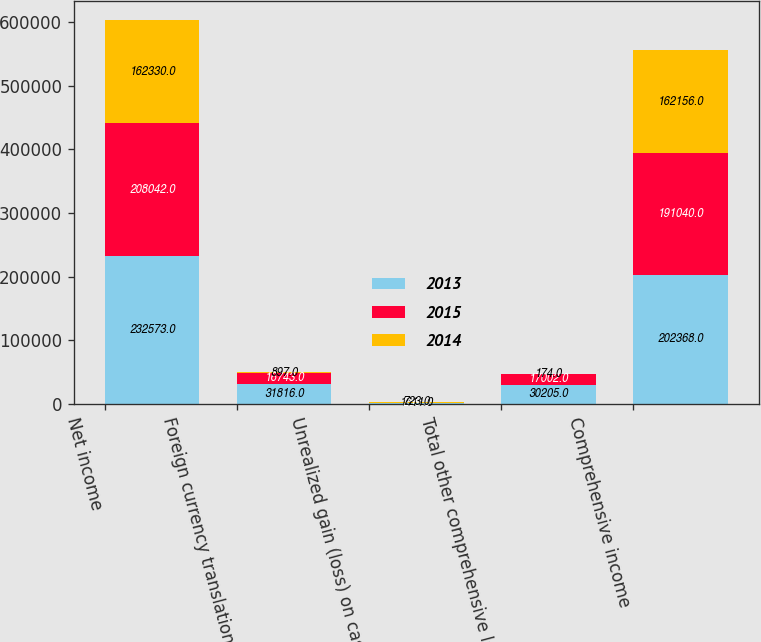Convert chart. <chart><loc_0><loc_0><loc_500><loc_500><stacked_bar_chart><ecel><fcel>Net income<fcel>Foreign currency translation<fcel>Unrealized gain (loss) on cash<fcel>Total other comprehensive loss<fcel>Comprehensive income<nl><fcel>2013<fcel>232573<fcel>31816<fcel>1611<fcel>30205<fcel>202368<nl><fcel>2015<fcel>208042<fcel>16743<fcel>259<fcel>17002<fcel>191040<nl><fcel>2014<fcel>162330<fcel>897<fcel>723<fcel>174<fcel>162156<nl></chart> 